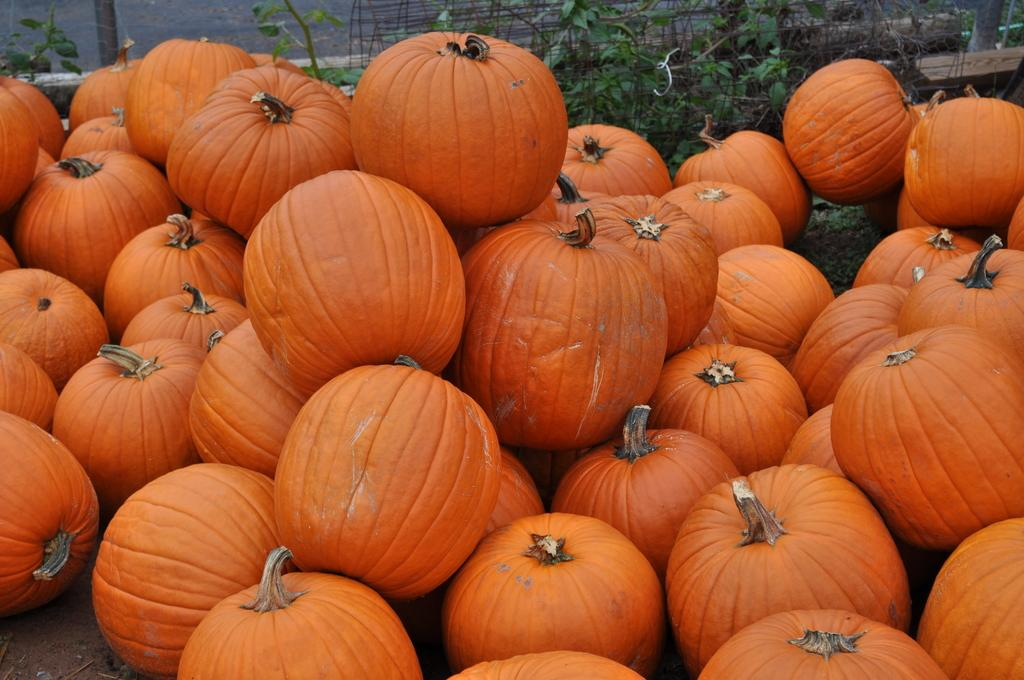What type of vegetable is present in the image? There are pumpkins in the image. What color are the pumpkins? The pumpkins are orange in color. What can be seen in the background of the image? There are plants and fencing in the background of the image. How many matches are needed to light the pumpkins in the image? There are no matches present in the image, and the pumpkins are not on fire. 